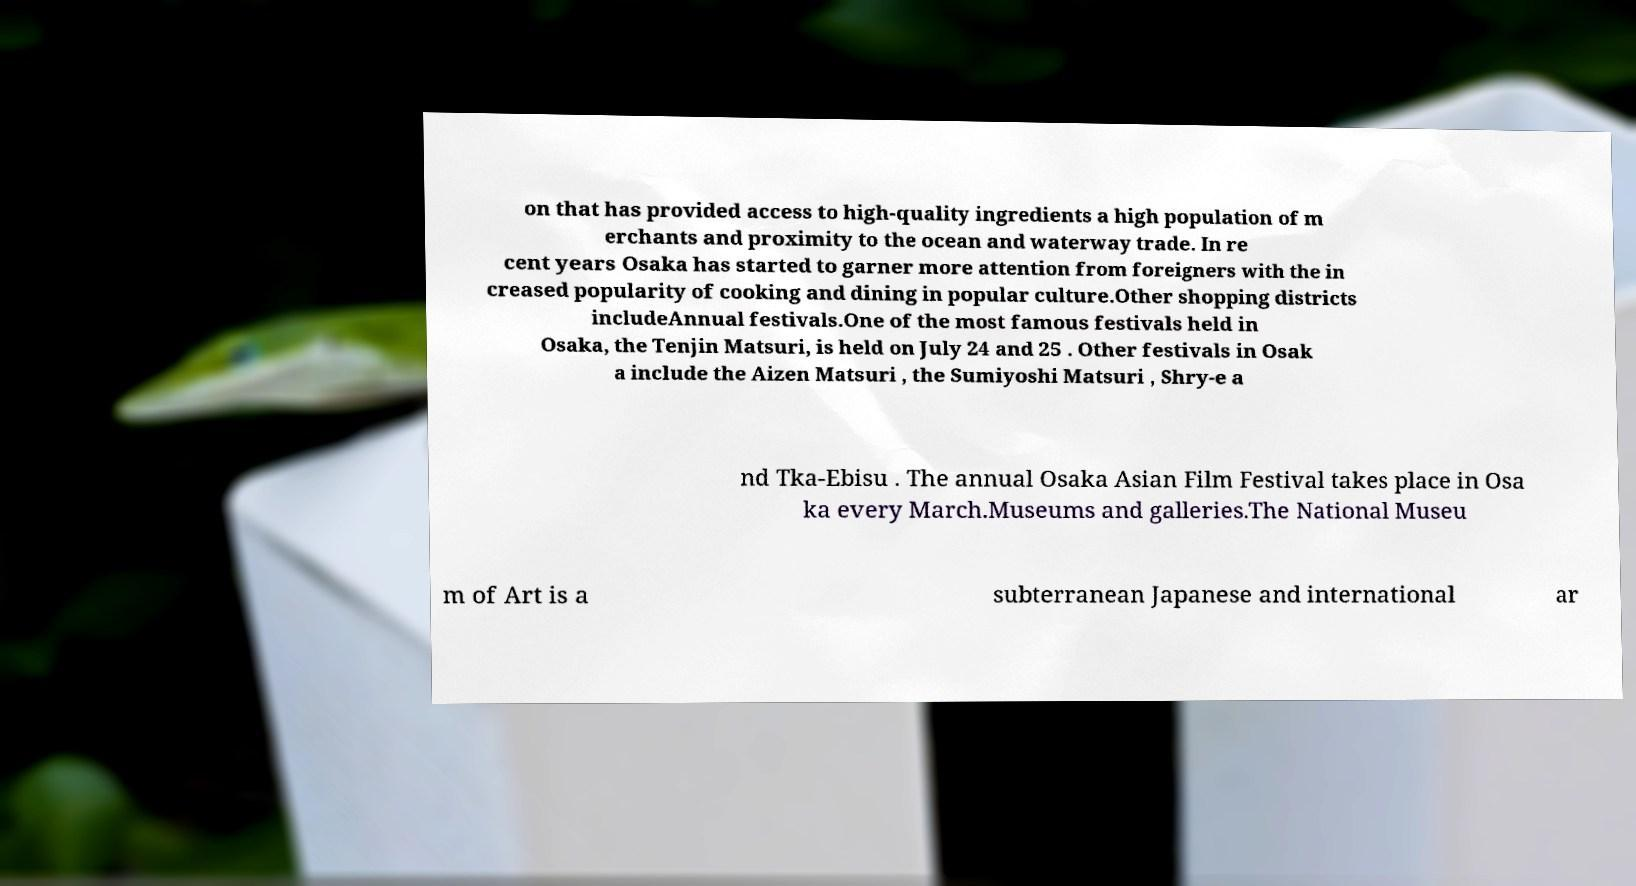Could you assist in decoding the text presented in this image and type it out clearly? on that has provided access to high-quality ingredients a high population of m erchants and proximity to the ocean and waterway trade. In re cent years Osaka has started to garner more attention from foreigners with the in creased popularity of cooking and dining in popular culture.Other shopping districts includeAnnual festivals.One of the most famous festivals held in Osaka, the Tenjin Matsuri, is held on July 24 and 25 . Other festivals in Osak a include the Aizen Matsuri , the Sumiyoshi Matsuri , Shry-e a nd Tka-Ebisu . The annual Osaka Asian Film Festival takes place in Osa ka every March.Museums and galleries.The National Museu m of Art is a subterranean Japanese and international ar 